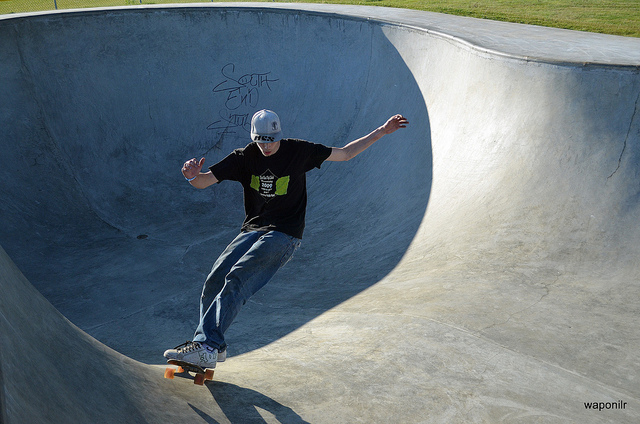Identify the text displayed in this image. waponilr South 